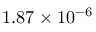<formula> <loc_0><loc_0><loc_500><loc_500>1 . 8 7 \times 1 0 ^ { - 6 }</formula> 